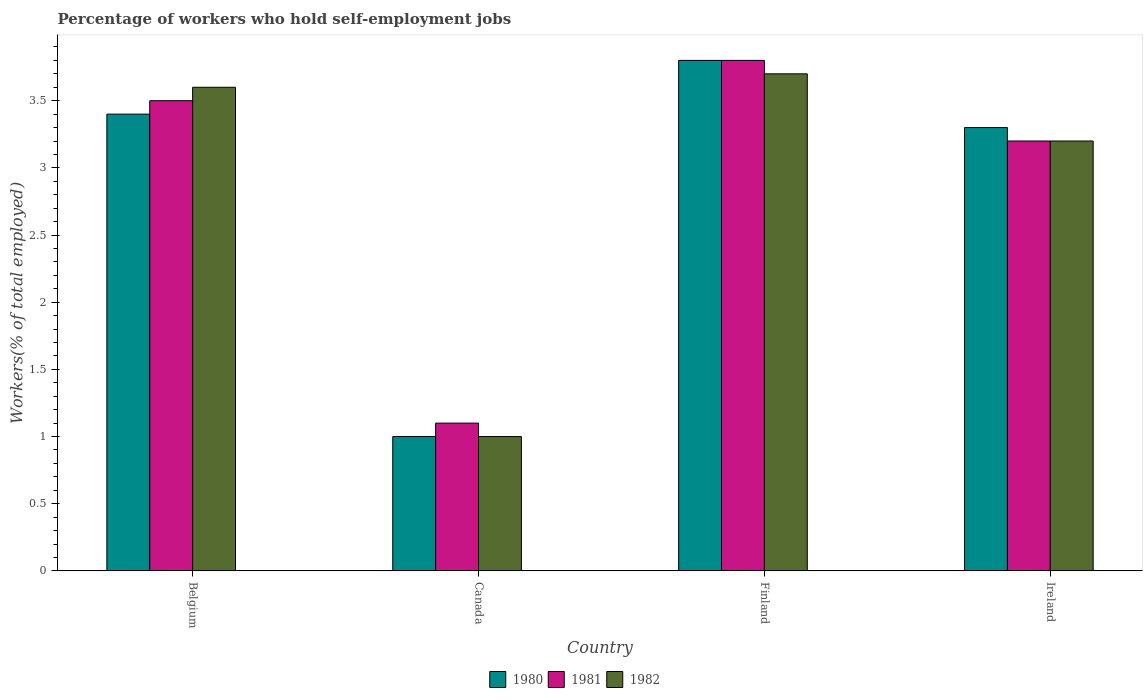How many different coloured bars are there?
Keep it short and to the point. 3. How many groups of bars are there?
Provide a short and direct response. 4. Are the number of bars on each tick of the X-axis equal?
Your response must be concise. Yes. How many bars are there on the 2nd tick from the left?
Your answer should be very brief. 3. How many bars are there on the 2nd tick from the right?
Ensure brevity in your answer.  3. What is the label of the 1st group of bars from the left?
Make the answer very short. Belgium. In how many cases, is the number of bars for a given country not equal to the number of legend labels?
Your answer should be compact. 0. What is the percentage of self-employed workers in 1981 in Ireland?
Keep it short and to the point. 3.2. Across all countries, what is the maximum percentage of self-employed workers in 1982?
Provide a short and direct response. 3.7. In which country was the percentage of self-employed workers in 1982 maximum?
Your answer should be compact. Finland. What is the total percentage of self-employed workers in 1980 in the graph?
Provide a short and direct response. 11.5. What is the difference between the percentage of self-employed workers in 1982 in Canada and that in Ireland?
Ensure brevity in your answer.  -2.2. What is the difference between the percentage of self-employed workers in 1982 in Belgium and the percentage of self-employed workers in 1980 in Ireland?
Keep it short and to the point. 0.3. What is the average percentage of self-employed workers in 1980 per country?
Provide a short and direct response. 2.87. What is the difference between the percentage of self-employed workers of/in 1982 and percentage of self-employed workers of/in 1980 in Ireland?
Offer a terse response. -0.1. In how many countries, is the percentage of self-employed workers in 1982 greater than 1.4 %?
Ensure brevity in your answer.  3. What is the ratio of the percentage of self-employed workers in 1981 in Belgium to that in Ireland?
Provide a succinct answer. 1.09. What is the difference between the highest and the second highest percentage of self-employed workers in 1981?
Offer a very short reply. 0.3. What is the difference between the highest and the lowest percentage of self-employed workers in 1982?
Ensure brevity in your answer.  2.7. In how many countries, is the percentage of self-employed workers in 1982 greater than the average percentage of self-employed workers in 1982 taken over all countries?
Make the answer very short. 3. What does the 1st bar from the left in Ireland represents?
Keep it short and to the point. 1980. What does the 3rd bar from the right in Canada represents?
Make the answer very short. 1980. Is it the case that in every country, the sum of the percentage of self-employed workers in 1981 and percentage of self-employed workers in 1982 is greater than the percentage of self-employed workers in 1980?
Your response must be concise. Yes. Are the values on the major ticks of Y-axis written in scientific E-notation?
Keep it short and to the point. No. Does the graph contain grids?
Give a very brief answer. No. How are the legend labels stacked?
Make the answer very short. Horizontal. What is the title of the graph?
Your answer should be very brief. Percentage of workers who hold self-employment jobs. What is the label or title of the X-axis?
Offer a very short reply. Country. What is the label or title of the Y-axis?
Offer a very short reply. Workers(% of total employed). What is the Workers(% of total employed) in 1980 in Belgium?
Provide a short and direct response. 3.4. What is the Workers(% of total employed) in 1982 in Belgium?
Give a very brief answer. 3.6. What is the Workers(% of total employed) of 1981 in Canada?
Ensure brevity in your answer.  1.1. What is the Workers(% of total employed) in 1982 in Canada?
Your answer should be compact. 1. What is the Workers(% of total employed) in 1980 in Finland?
Provide a succinct answer. 3.8. What is the Workers(% of total employed) in 1981 in Finland?
Provide a succinct answer. 3.8. What is the Workers(% of total employed) of 1982 in Finland?
Your answer should be compact. 3.7. What is the Workers(% of total employed) in 1980 in Ireland?
Your answer should be very brief. 3.3. What is the Workers(% of total employed) in 1981 in Ireland?
Provide a succinct answer. 3.2. What is the Workers(% of total employed) of 1982 in Ireland?
Offer a very short reply. 3.2. Across all countries, what is the maximum Workers(% of total employed) of 1980?
Give a very brief answer. 3.8. Across all countries, what is the maximum Workers(% of total employed) of 1981?
Offer a very short reply. 3.8. Across all countries, what is the maximum Workers(% of total employed) of 1982?
Your response must be concise. 3.7. Across all countries, what is the minimum Workers(% of total employed) of 1980?
Offer a terse response. 1. Across all countries, what is the minimum Workers(% of total employed) of 1981?
Offer a very short reply. 1.1. Across all countries, what is the minimum Workers(% of total employed) in 1982?
Make the answer very short. 1. What is the total Workers(% of total employed) in 1980 in the graph?
Your answer should be very brief. 11.5. What is the total Workers(% of total employed) in 1981 in the graph?
Offer a terse response. 11.6. What is the total Workers(% of total employed) of 1982 in the graph?
Your answer should be very brief. 11.5. What is the difference between the Workers(% of total employed) in 1980 in Belgium and that in Canada?
Provide a succinct answer. 2.4. What is the difference between the Workers(% of total employed) of 1980 in Belgium and that in Finland?
Ensure brevity in your answer.  -0.4. What is the difference between the Workers(% of total employed) of 1981 in Belgium and that in Finland?
Your response must be concise. -0.3. What is the difference between the Workers(% of total employed) in 1981 in Belgium and that in Ireland?
Your answer should be very brief. 0.3. What is the difference between the Workers(% of total employed) in 1982 in Belgium and that in Ireland?
Ensure brevity in your answer.  0.4. What is the difference between the Workers(% of total employed) in 1981 in Canada and that in Finland?
Your answer should be compact. -2.7. What is the difference between the Workers(% of total employed) of 1980 in Canada and that in Ireland?
Make the answer very short. -2.3. What is the difference between the Workers(% of total employed) of 1982 in Canada and that in Ireland?
Your answer should be very brief. -2.2. What is the difference between the Workers(% of total employed) of 1980 in Finland and that in Ireland?
Provide a succinct answer. 0.5. What is the difference between the Workers(% of total employed) in 1981 in Finland and that in Ireland?
Offer a very short reply. 0.6. What is the difference between the Workers(% of total employed) of 1980 in Belgium and the Workers(% of total employed) of 1981 in Canada?
Your answer should be compact. 2.3. What is the difference between the Workers(% of total employed) in 1981 in Belgium and the Workers(% of total employed) in 1982 in Canada?
Offer a terse response. 2.5. What is the difference between the Workers(% of total employed) in 1980 in Belgium and the Workers(% of total employed) in 1981 in Finland?
Provide a short and direct response. -0.4. What is the difference between the Workers(% of total employed) of 1981 in Belgium and the Workers(% of total employed) of 1982 in Finland?
Your response must be concise. -0.2. What is the difference between the Workers(% of total employed) in 1980 in Belgium and the Workers(% of total employed) in 1982 in Ireland?
Make the answer very short. 0.2. What is the difference between the Workers(% of total employed) in 1981 in Belgium and the Workers(% of total employed) in 1982 in Ireland?
Your response must be concise. 0.3. What is the difference between the Workers(% of total employed) in 1981 in Canada and the Workers(% of total employed) in 1982 in Finland?
Provide a short and direct response. -2.6. What is the difference between the Workers(% of total employed) of 1980 in Canada and the Workers(% of total employed) of 1982 in Ireland?
Make the answer very short. -2.2. What is the difference between the Workers(% of total employed) of 1980 in Finland and the Workers(% of total employed) of 1981 in Ireland?
Make the answer very short. 0.6. What is the difference between the Workers(% of total employed) of 1980 in Finland and the Workers(% of total employed) of 1982 in Ireland?
Offer a very short reply. 0.6. What is the difference between the Workers(% of total employed) of 1981 in Finland and the Workers(% of total employed) of 1982 in Ireland?
Give a very brief answer. 0.6. What is the average Workers(% of total employed) in 1980 per country?
Make the answer very short. 2.88. What is the average Workers(% of total employed) of 1981 per country?
Offer a very short reply. 2.9. What is the average Workers(% of total employed) of 1982 per country?
Offer a very short reply. 2.88. What is the difference between the Workers(% of total employed) in 1980 and Workers(% of total employed) in 1982 in Belgium?
Keep it short and to the point. -0.2. What is the difference between the Workers(% of total employed) of 1981 and Workers(% of total employed) of 1982 in Belgium?
Provide a short and direct response. -0.1. What is the difference between the Workers(% of total employed) of 1980 and Workers(% of total employed) of 1982 in Canada?
Offer a terse response. 0. What is the difference between the Workers(% of total employed) in 1981 and Workers(% of total employed) in 1982 in Canada?
Ensure brevity in your answer.  0.1. What is the difference between the Workers(% of total employed) in 1980 and Workers(% of total employed) in 1982 in Finland?
Keep it short and to the point. 0.1. What is the difference between the Workers(% of total employed) in 1981 and Workers(% of total employed) in 1982 in Finland?
Make the answer very short. 0.1. What is the difference between the Workers(% of total employed) in 1980 and Workers(% of total employed) in 1981 in Ireland?
Your response must be concise. 0.1. What is the ratio of the Workers(% of total employed) in 1980 in Belgium to that in Canada?
Provide a succinct answer. 3.4. What is the ratio of the Workers(% of total employed) of 1981 in Belgium to that in Canada?
Keep it short and to the point. 3.18. What is the ratio of the Workers(% of total employed) of 1980 in Belgium to that in Finland?
Offer a terse response. 0.89. What is the ratio of the Workers(% of total employed) of 1981 in Belgium to that in Finland?
Your answer should be compact. 0.92. What is the ratio of the Workers(% of total employed) in 1982 in Belgium to that in Finland?
Your response must be concise. 0.97. What is the ratio of the Workers(% of total employed) of 1980 in Belgium to that in Ireland?
Provide a short and direct response. 1.03. What is the ratio of the Workers(% of total employed) in 1981 in Belgium to that in Ireland?
Your response must be concise. 1.09. What is the ratio of the Workers(% of total employed) of 1982 in Belgium to that in Ireland?
Your response must be concise. 1.12. What is the ratio of the Workers(% of total employed) of 1980 in Canada to that in Finland?
Give a very brief answer. 0.26. What is the ratio of the Workers(% of total employed) in 1981 in Canada to that in Finland?
Provide a short and direct response. 0.29. What is the ratio of the Workers(% of total employed) of 1982 in Canada to that in Finland?
Give a very brief answer. 0.27. What is the ratio of the Workers(% of total employed) in 1980 in Canada to that in Ireland?
Your answer should be compact. 0.3. What is the ratio of the Workers(% of total employed) in 1981 in Canada to that in Ireland?
Make the answer very short. 0.34. What is the ratio of the Workers(% of total employed) of 1982 in Canada to that in Ireland?
Offer a very short reply. 0.31. What is the ratio of the Workers(% of total employed) of 1980 in Finland to that in Ireland?
Keep it short and to the point. 1.15. What is the ratio of the Workers(% of total employed) of 1981 in Finland to that in Ireland?
Give a very brief answer. 1.19. What is the ratio of the Workers(% of total employed) of 1982 in Finland to that in Ireland?
Provide a succinct answer. 1.16. What is the difference between the highest and the second highest Workers(% of total employed) of 1980?
Your response must be concise. 0.4. What is the difference between the highest and the lowest Workers(% of total employed) of 1982?
Your answer should be very brief. 2.7. 